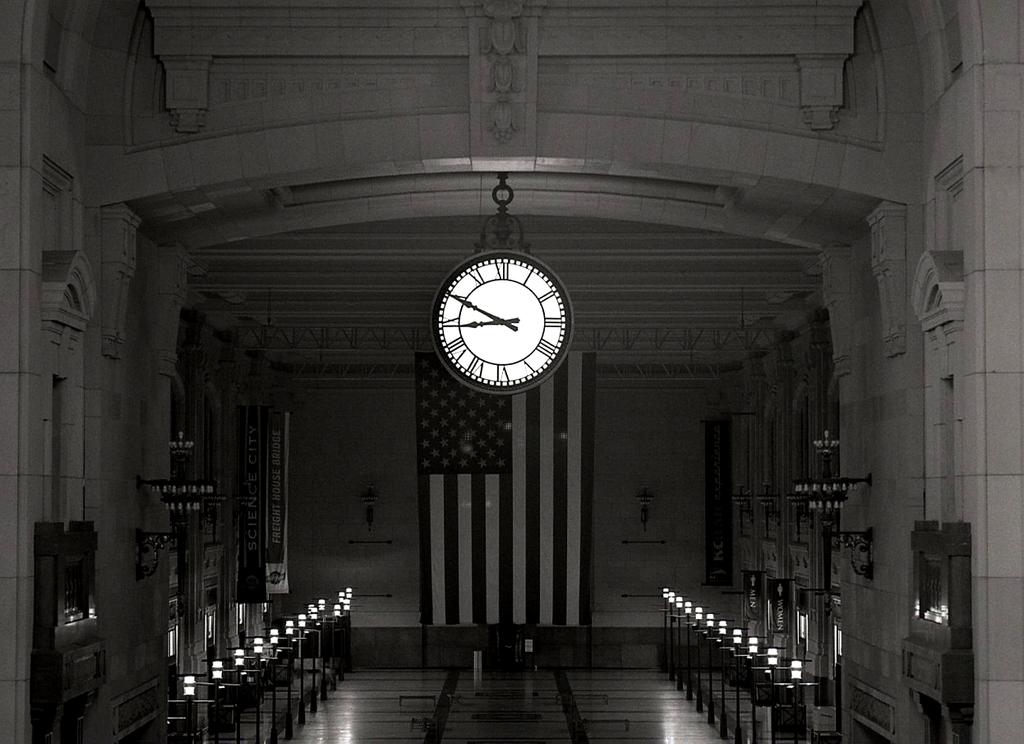What is on the banner on the left?
Make the answer very short. Science city. 